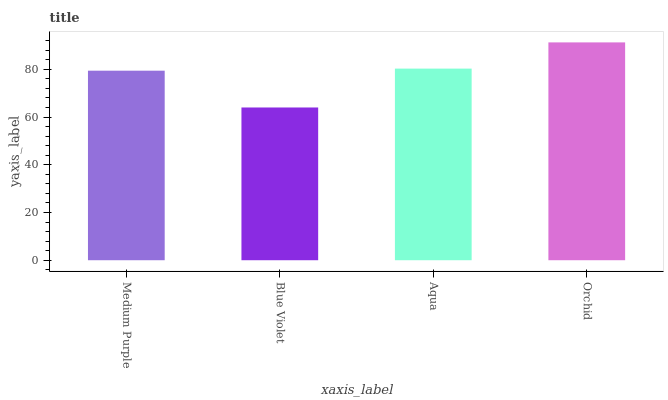Is Blue Violet the minimum?
Answer yes or no. Yes. Is Orchid the maximum?
Answer yes or no. Yes. Is Aqua the minimum?
Answer yes or no. No. Is Aqua the maximum?
Answer yes or no. No. Is Aqua greater than Blue Violet?
Answer yes or no. Yes. Is Blue Violet less than Aqua?
Answer yes or no. Yes. Is Blue Violet greater than Aqua?
Answer yes or no. No. Is Aqua less than Blue Violet?
Answer yes or no. No. Is Aqua the high median?
Answer yes or no. Yes. Is Medium Purple the low median?
Answer yes or no. Yes. Is Blue Violet the high median?
Answer yes or no. No. Is Aqua the low median?
Answer yes or no. No. 